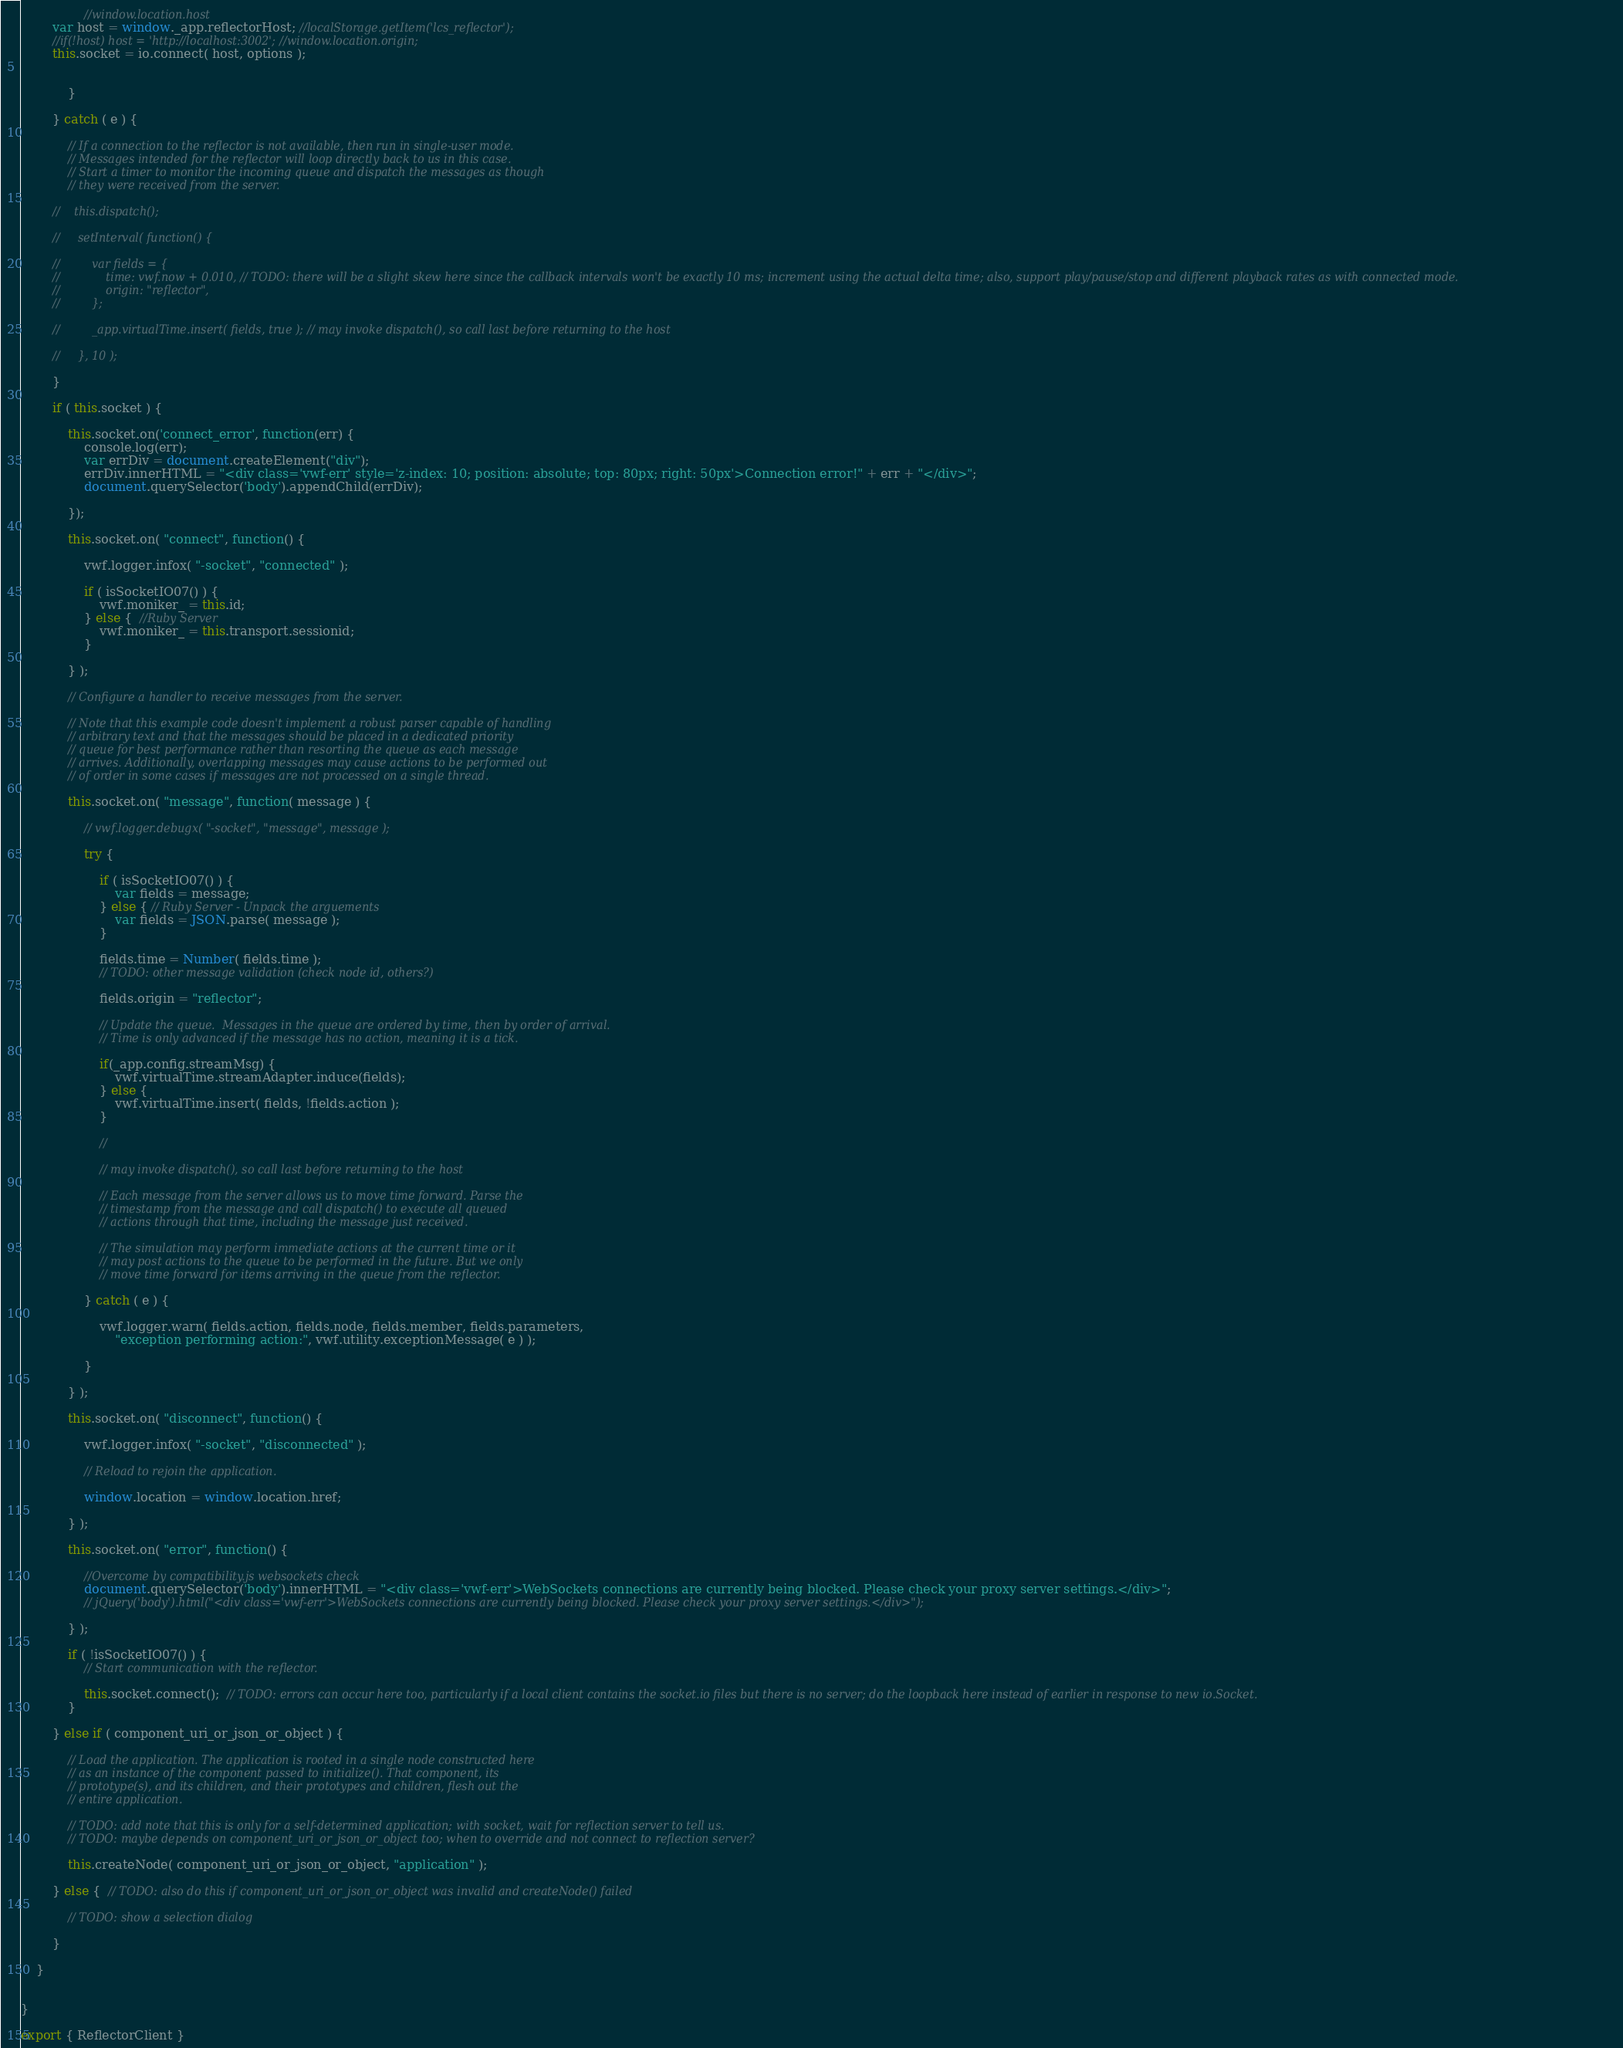Convert code to text. <code><loc_0><loc_0><loc_500><loc_500><_JavaScript_>                //window.location.host
        var host = window._app.reflectorHost; //localStorage.getItem('lcs_reflector'); 
        //if(!host) host = 'http://localhost:3002'; //window.location.origin;       
        this.socket = io.connect( host, options );
                

            } 

        } catch ( e ) {

            // If a connection to the reflector is not available, then run in single-user mode.
            // Messages intended for the reflector will loop directly back to us in this case.
            // Start a timer to monitor the incoming queue and dispatch the messages as though
            // they were received from the server.

        //    this.dispatch();

        //     setInterval( function() {

        //         var fields = {
        //             time: vwf.now + 0.010, // TODO: there will be a slight skew here since the callback intervals won't be exactly 10 ms; increment using the actual delta time; also, support play/pause/stop and different playback rates as with connected mode.
        //             origin: "reflector",
        //         };

        //         _app.virtualTime.insert( fields, true ); // may invoke dispatch(), so call last before returning to the host

        //     }, 10 );

        }

        if ( this.socket ) {

            this.socket.on('connect_error', function(err) {
                console.log(err);
                var errDiv = document.createElement("div");
                errDiv.innerHTML = "<div class='vwf-err' style='z-index: 10; position: absolute; top: 80px; right: 50px'>Connection error!" + err + "</div>";
                document.querySelector('body').appendChild(errDiv);
                
            });

            this.socket.on( "connect", function() {

                vwf.logger.infox( "-socket", "connected" );

                if ( isSocketIO07() ) {
                    vwf.moniker_ = this.id;                        
                } else {  //Ruby Server
                    vwf.moniker_ = this.transport.sessionid;
                }

            } );

            // Configure a handler to receive messages from the server.
            
            // Note that this example code doesn't implement a robust parser capable of handling
            // arbitrary text and that the messages should be placed in a dedicated priority
            // queue for best performance rather than resorting the queue as each message
            // arrives. Additionally, overlapping messages may cause actions to be performed out
            // of order in some cases if messages are not processed on a single thread.

            this.socket.on( "message", function( message ) {

                // vwf.logger.debugx( "-socket", "message", message );

                try {

                    if ( isSocketIO07() ) {
                        var fields = message;
                    } else { // Ruby Server - Unpack the arguements
                        var fields = JSON.parse( message );
                    }

                    fields.time = Number( fields.time );
                    // TODO: other message validation (check node id, others?)

                    fields.origin = "reflector";

                    // Update the queue.  Messages in the queue are ordered by time, then by order of arrival.
                    // Time is only advanced if the message has no action, meaning it is a tick.

                    if(_app.config.streamMsg) {
                        vwf.virtualTime.streamAdapter.induce(fields);
                    } else {
                        vwf.virtualTime.insert( fields, !fields.action ); 
                    }
                    
                    //
                    
                    // may invoke dispatch(), so call last before returning to the host

                    // Each message from the server allows us to move time forward. Parse the
                    // timestamp from the message and call dispatch() to execute all queued
                    // actions through that time, including the message just received.
                
                    // The simulation may perform immediate actions at the current time or it
                    // may post actions to the queue to be performed in the future. But we only
                    // move time forward for items arriving in the queue from the reflector.

                } catch ( e ) {

                    vwf.logger.warn( fields.action, fields.node, fields.member, fields.parameters,
                        "exception performing action:", vwf.utility.exceptionMessage( e ) );

                }

            } );

            this.socket.on( "disconnect", function() {

                vwf.logger.infox( "-socket", "disconnected" );

                // Reload to rejoin the application.

                window.location = window.location.href;

            } );

            this.socket.on( "error", function() { 

                //Overcome by compatibility.js websockets check
                document.querySelector('body').innerHTML = "<div class='vwf-err'>WebSockets connections are currently being blocked. Please check your proxy server settings.</div>";
                // jQuery('body').html("<div class='vwf-err'>WebSockets connections are currently being blocked. Please check your proxy server settings.</div>"); 

            } );

            if ( !isSocketIO07() ) {
                // Start communication with the reflector. 

                this.socket.connect();  // TODO: errors can occur here too, particularly if a local client contains the socket.io files but there is no server; do the loopback here instead of earlier in response to new io.Socket.
            }

        } else if ( component_uri_or_json_or_object ) {

            // Load the application. The application is rooted in a single node constructed here
            // as an instance of the component passed to initialize(). That component, its
            // prototype(s), and its children, and their prototypes and children, flesh out the
            // entire application.

            // TODO: add note that this is only for a self-determined application; with socket, wait for reflection server to tell us.
            // TODO: maybe depends on component_uri_or_json_or_object too; when to override and not connect to reflection server?

            this.createNode( component_uri_or_json_or_object, "application" );

        } else {  // TODO: also do this if component_uri_or_json_or_object was invalid and createNode() failed

            // TODO: show a selection dialog

        }

    }


}

export { ReflectorClient }</code> 